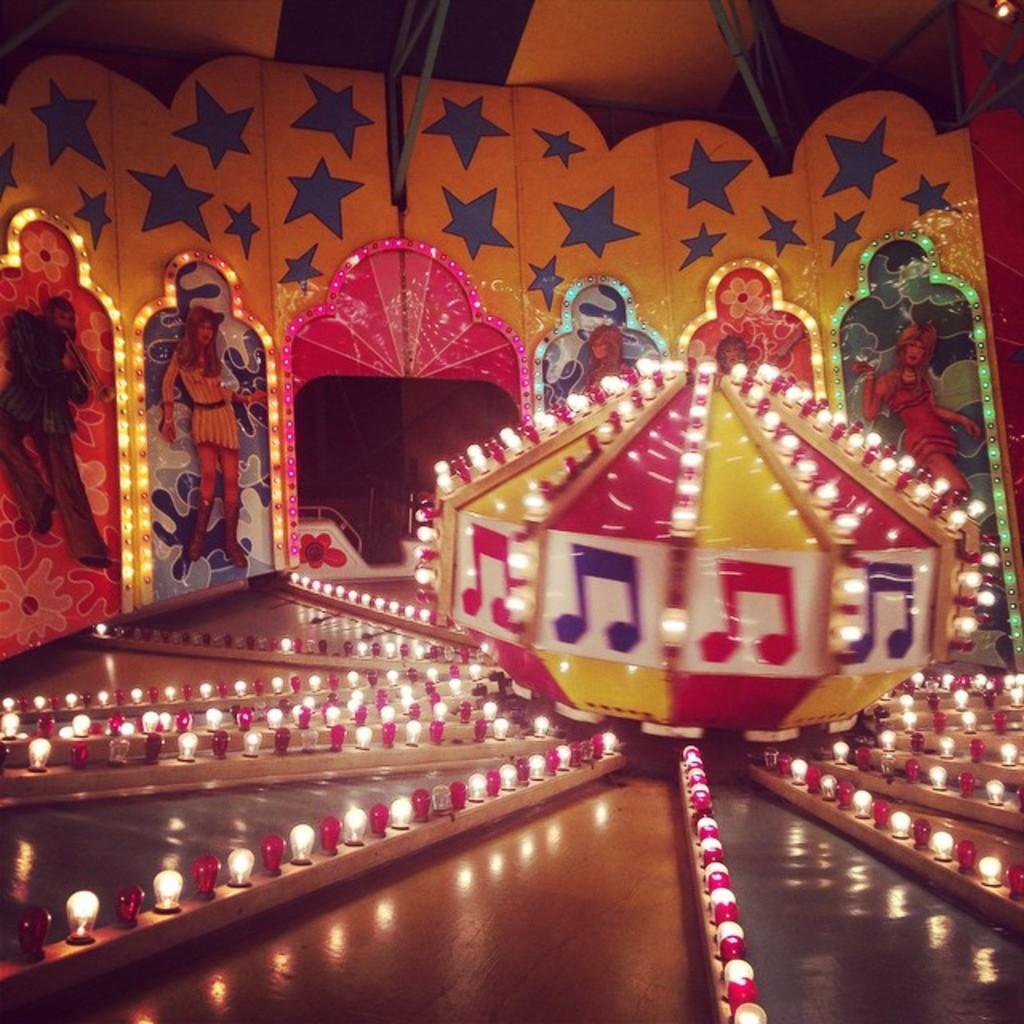Could you give a brief overview of what you see in this image? In this image there are lights, behind the lights there is an object decorated with lights, behind that the wall is decorated with stars, lights, pictures of few people and there is an entrance, in that we can see the metal rod fence, at the top of the image there are metal rods and lights. 